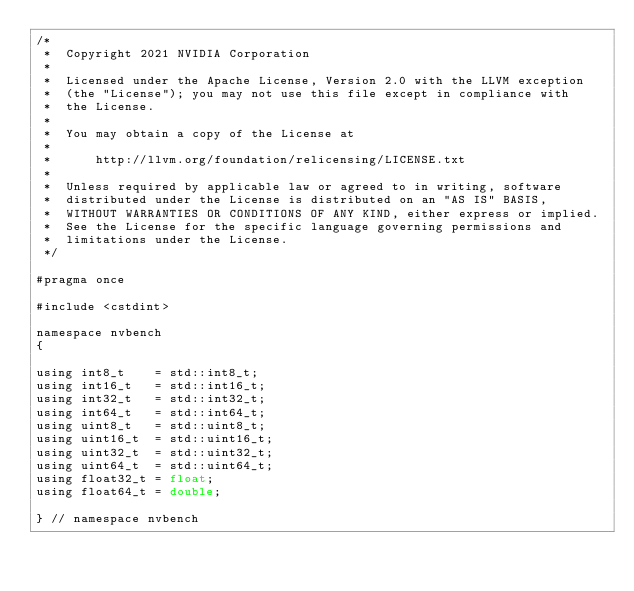Convert code to text. <code><loc_0><loc_0><loc_500><loc_500><_Cuda_>/*
 *  Copyright 2021 NVIDIA Corporation
 *
 *  Licensed under the Apache License, Version 2.0 with the LLVM exception
 *  (the "License"); you may not use this file except in compliance with
 *  the License.
 *
 *  You may obtain a copy of the License at
 *
 *      http://llvm.org/foundation/relicensing/LICENSE.txt
 *
 *  Unless required by applicable law or agreed to in writing, software
 *  distributed under the License is distributed on an "AS IS" BASIS,
 *  WITHOUT WARRANTIES OR CONDITIONS OF ANY KIND, either express or implied.
 *  See the License for the specific language governing permissions and
 *  limitations under the License.
 */

#pragma once

#include <cstdint>

namespace nvbench
{

using int8_t    = std::int8_t;
using int16_t   = std::int16_t;
using int32_t   = std::int32_t;
using int64_t   = std::int64_t;
using uint8_t   = std::uint8_t;
using uint16_t  = std::uint16_t;
using uint32_t  = std::uint32_t;
using uint64_t  = std::uint64_t;
using float32_t = float;
using float64_t = double;

} // namespace nvbench
</code> 